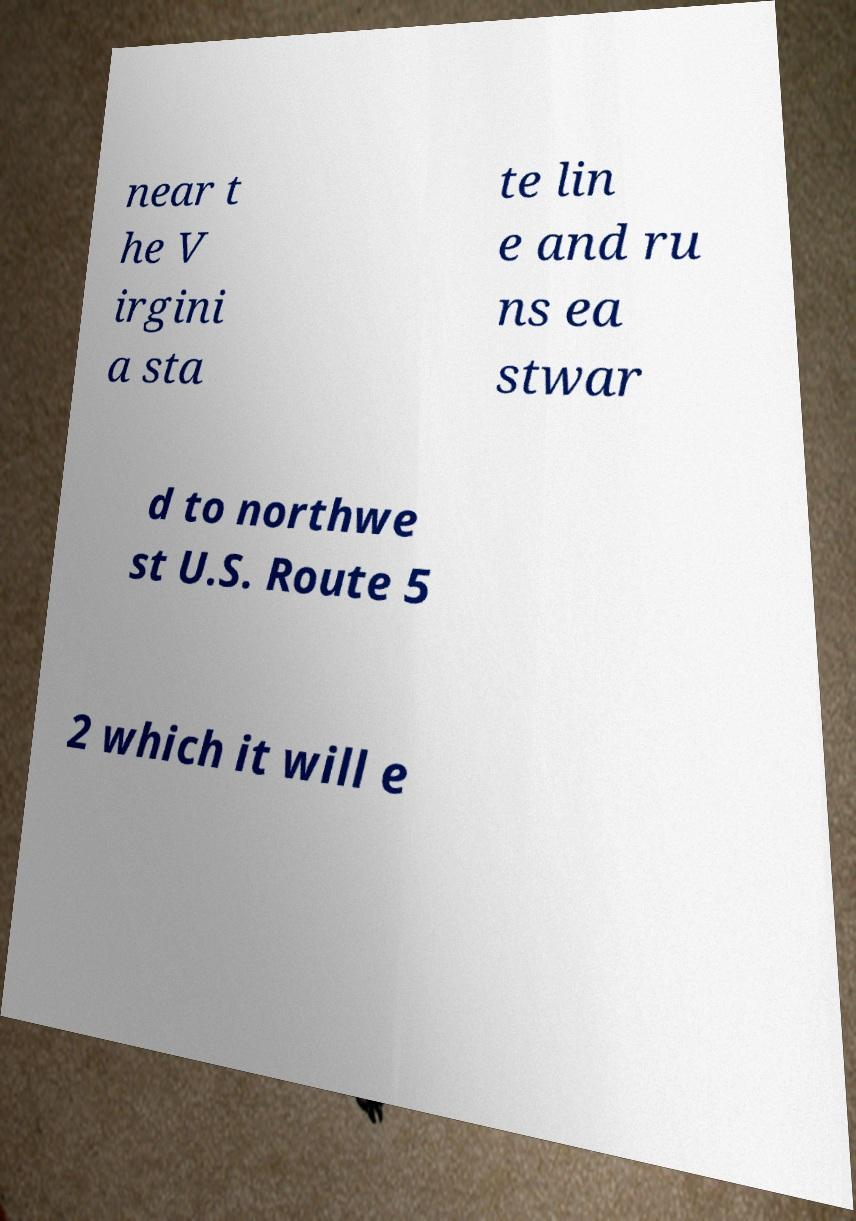Please read and relay the text visible in this image. What does it say? near t he V irgini a sta te lin e and ru ns ea stwar d to northwe st U.S. Route 5 2 which it will e 